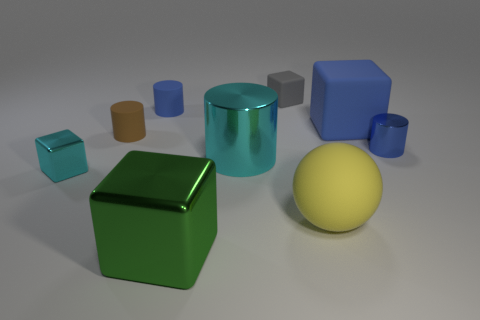How many yellow spheres have the same material as the tiny brown thing? 1 